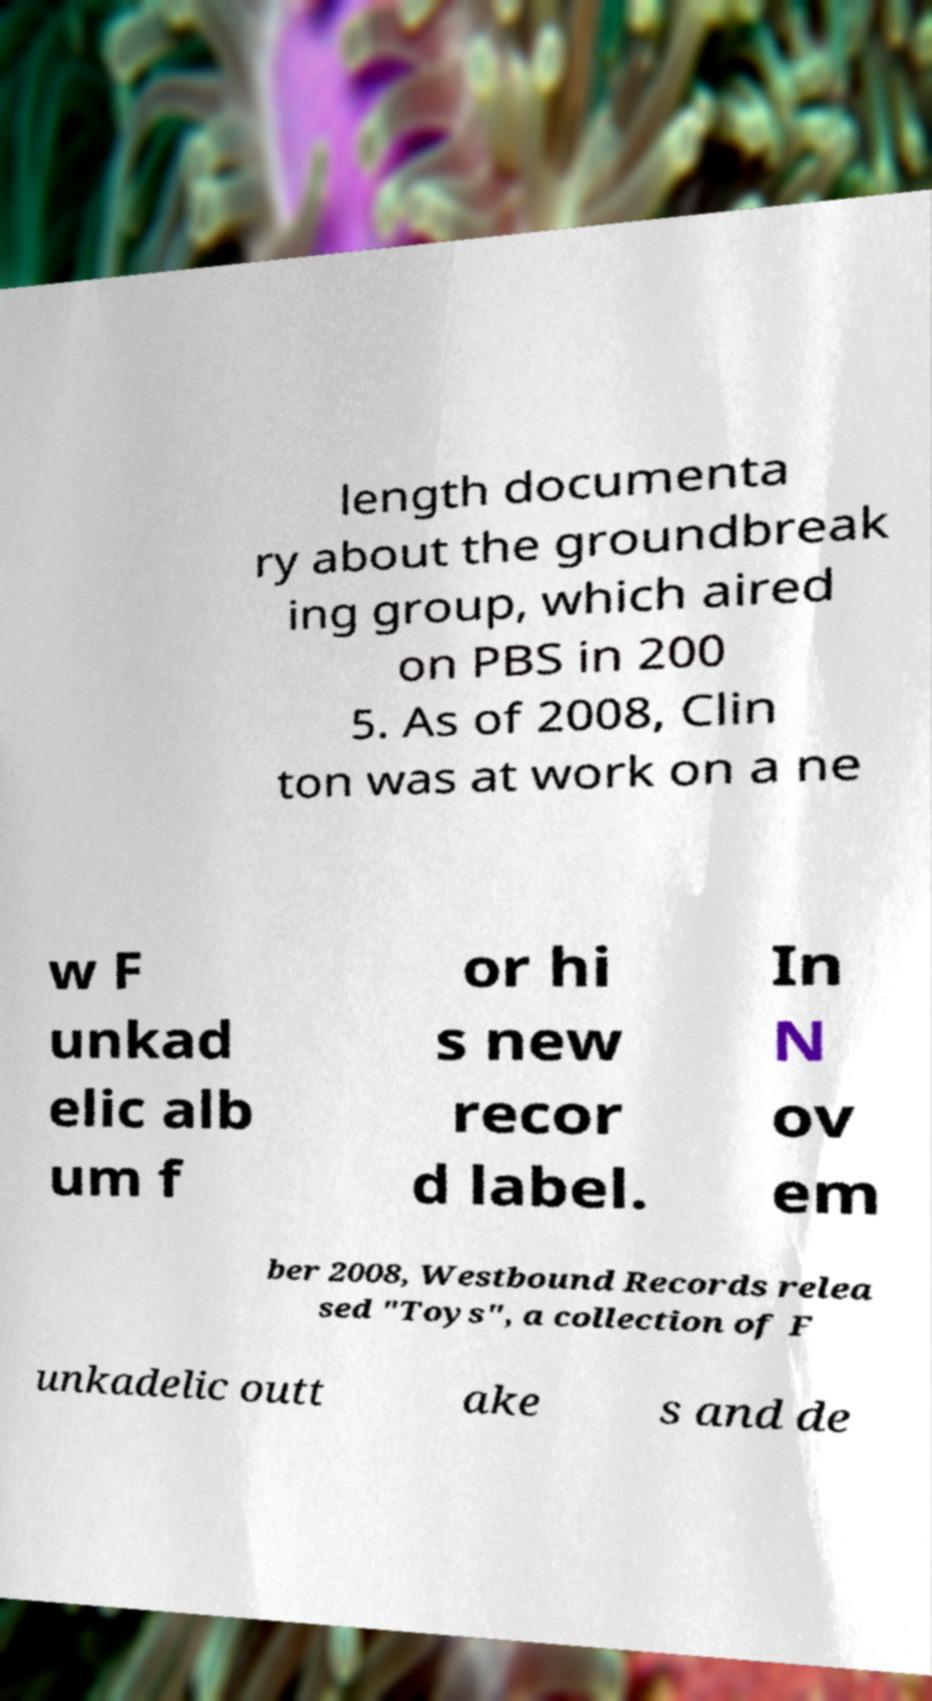I need the written content from this picture converted into text. Can you do that? length documenta ry about the groundbreak ing group, which aired on PBS in 200 5. As of 2008, Clin ton was at work on a ne w F unkad elic alb um f or hi s new recor d label. In N ov em ber 2008, Westbound Records relea sed "Toys", a collection of F unkadelic outt ake s and de 